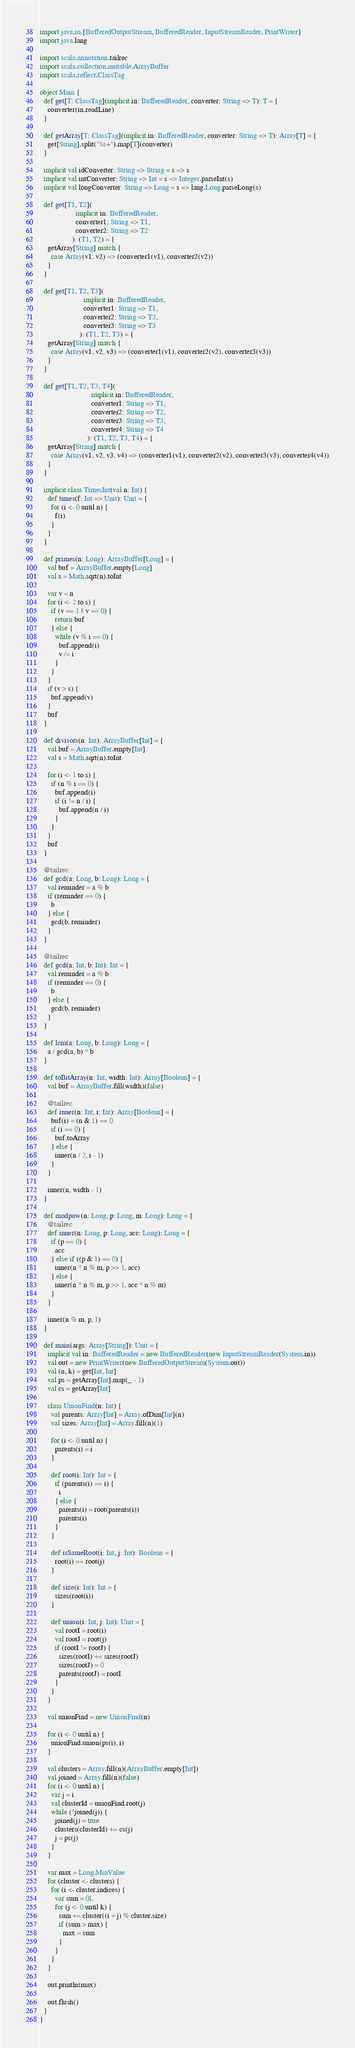Convert code to text. <code><loc_0><loc_0><loc_500><loc_500><_Scala_>import java.io.{BufferedOutputStream, BufferedReader, InputStreamReader, PrintWriter}
import java.lang

import scala.annotation.tailrec
import scala.collection.mutable.ArrayBuffer
import scala.reflect.ClassTag

object Main {
  def get[T: ClassTag](implicit in: BufferedReader, converter: String => T): T = {
    converter(in.readLine)
  }

  def getArray[T: ClassTag](implicit in: BufferedReader, converter: String => T): Array[T] = {
    get[String].split("\\s+").map[T](converter)
  }

  implicit val idConverter: String => String = s => s
  implicit val intConverter: String => Int = s => Integer.parseInt(s)
  implicit val longConverter: String => Long = s => lang.Long.parseLong(s)

  def get[T1, T2](
                   implicit in: BufferedReader,
                   converter1: String => T1,
                   converter2: String => T2
                 ): (T1, T2) = {
    getArray[String] match {
      case Array(v1, v2) => (converter1(v1), converter2(v2))
    }
  }

  def get[T1, T2, T3](
                       implicit in: BufferedReader,
                       converter1: String => T1,
                       converter2: String => T2,
                       converter3: String => T3
                     ): (T1, T2, T3) = {
    getArray[String] match {
      case Array(v1, v2, v3) => (converter1(v1), converter2(v2), converter3(v3))
    }
  }

  def get[T1, T2, T3, T4](
                           implicit in: BufferedReader,
                           converter1: String => T1,
                           converter2: String => T2,
                           converter3: String => T3,
                           converter4: String => T4
                         ): (T1, T2, T3, T4) = {
    getArray[String] match {
      case Array(v1, v2, v3, v4) => (converter1(v1), converter2(v2), converter3(v3), converter4(v4))
    }
  }

  implicit class TimesInt(val n: Int) {
    def times(f: Int => Unit): Unit = {
      for (i <- 0 until n) {
        f(i)
      }
    }
  }

  def primes(n: Long): ArrayBuffer[Long] = {
    val buf = ArrayBuffer.empty[Long]
    val s = Math.sqrt(n).toInt

    var v = n
    for (i <- 2 to s) {
      if (v == 1 || v == 0) {
        return buf
      } else {
        while (v % i == 0) {
          buf.append(i)
          v /= i
        }
      }
    }
    if (v > s) {
      buf.append(v)
    }
    buf
  }

  def divisors(n: Int): ArrayBuffer[Int] = {
    val buf = ArrayBuffer.empty[Int]
    val s = Math.sqrt(n).toInt

    for (i <- 1 to s) {
      if (n % i == 0) {
        buf.append(i)
        if (i != n / i) {
          buf.append(n / i)
        }
      }
    }
    buf
  }

  @tailrec
  def gcd(a: Long, b: Long): Long = {
    val reminder = a % b
    if (reminder == 0) {
      b
    } else {
      gcd(b, reminder)
    }
  }

  @tailrec
  def gcd(a: Int, b: Int): Int = {
    val reminder = a % b
    if (reminder == 0) {
      b
    } else {
      gcd(b, reminder)
    }
  }

  def lcm(a: Long, b: Long): Long = {
    a / gcd(a, b) * b
  }

  def toBitArray(n: Int, width: Int): Array[Boolean] = {
    val buf = ArrayBuffer.fill(width)(false)

    @tailrec
    def inner(n: Int, i: Int): Array[Boolean] = {
      buf(i) = (n & 1) == 0
      if (i == 0) {
        buf.toArray
      } else {
        inner(n / 2, i - 1)
      }
    }

    inner(n, width - 1)
  }

  def modpow(n: Long, p: Long, m: Long): Long = {
    @tailrec
    def inner(n: Long, p: Long, acc: Long): Long = {
      if (p == 0) {
        acc
      } else if ((p & 1) == 0) {
        inner(n * n % m, p >> 1, acc)
      } else {
        inner(n * n % m, p >> 1, acc * n % m)
      }
    }

    inner(n % m, p, 1)
  }

  def main(args: Array[String]): Unit = {
    implicit val in: BufferedReader = new BufferedReader(new InputStreamReader(System.in))
    val out = new PrintWriter(new BufferedOutputStream(System.out))
    val (n, k) = get[Int, Int]
    val ps = getArray[Int].map(_ - 1)
    val cs = getArray[Int]

    class UnionFind(n: Int) {
      val parents: Array[Int] = Array.ofDim[Int](n)
      val sizes: Array[Int] = Array.fill(n)(1)

      for (i <- 0 until n) {
        parents(i) = i
      }

      def root(i: Int): Int = {
        if (parents(i) == i) {
          i
        } else {
          parents(i) = root(parents(i))
          parents(i)
        }
      }

      def isSameRoot(i: Int, j: Int): Boolean = {
        root(i) == root(j)
      }

      def size(i: Int): Int = {
        sizes(root(i))
      }

      def union(i: Int, j: Int): Unit = {
        val rootI = root(i)
        val rootJ = root(j)
        if (rootI != rootJ) {
          sizes(rootI) += sizes(rootJ)
          sizes(rootJ) = 0
          parents(rootJ) = rootI
        }
      }
    }

    val unionFind = new UnionFind(n)

    for (i <- 0 until n) {
      unionFind.union(ps(i), i)
    }

    val clusters = Array.fill(n)(ArrayBuffer.empty[Int])
    val joined = Array.fill(n)(false)
    for (i <- 0 until n) {
      var j = i
      val clusterId = unionFind.root(j)
      while (!joined(j)) {
        joined(j) = true
        clusters(clusterId) += cs(j)
        j = ps(j)
      }
    }

    var max = Long.MinValue
    for (cluster <- clusters) {
      for (i <- cluster.indices) {
        var sum = 0L
        for (j <- 0 until k) {
          sum += cluster((i + j) % cluster.size)
          if (sum > max) {
            max = sum
          }
        }
      }
    }

    out.println(max)

    out.flush()
  }
}</code> 